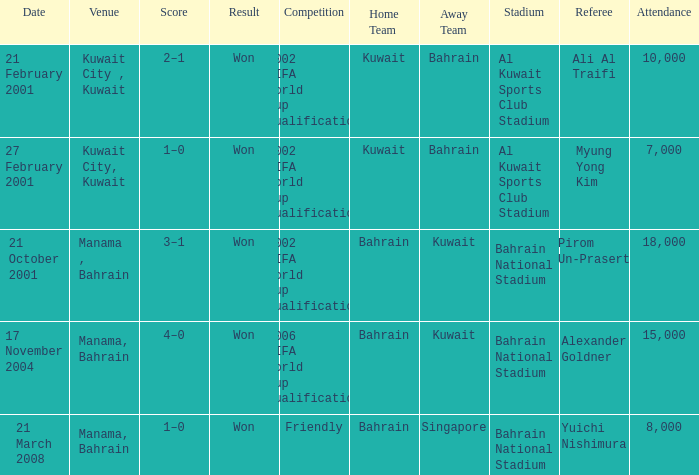On which date was the 2006 FIFA World Cup Qualification in Manama, Bahrain? 17 November 2004. Parse the full table. {'header': ['Date', 'Venue', 'Score', 'Result', 'Competition', 'Home Team', 'Away Team', 'Stadium', 'Referee', 'Attendance'], 'rows': [['21 February 2001', 'Kuwait City , Kuwait', '2–1', 'Won', '2002 FIFA World Cup qualification', 'Kuwait', 'Bahrain', 'Al Kuwait Sports Club Stadium', 'Ali Al Traifi', '10,000'], ['27 February 2001', 'Kuwait City, Kuwait', '1–0', 'Won', '2002 FIFA World Cup qualification', 'Kuwait', 'Bahrain', 'Al Kuwait Sports Club Stadium', 'Myung Yong Kim', '7,000'], ['21 October 2001', 'Manama , Bahrain', '3–1', 'Won', '2002 FIFA World Cup qualification', 'Bahrain', 'Kuwait', 'Bahrain National Stadium', 'Pirom Un-Prasert', '18,000'], ['17 November 2004', 'Manama, Bahrain', '4–0', 'Won', '2006 FIFA World Cup qualification', 'Bahrain', 'Kuwait', 'Bahrain National Stadium', 'Alexander Goldner', '15,000'], ['21 March 2008', 'Manama, Bahrain', '1–0', 'Won', 'Friendly', 'Bahrain', 'Singapore', 'Bahrain National Stadium', 'Yuichi Nishimura', '8,000']]} 